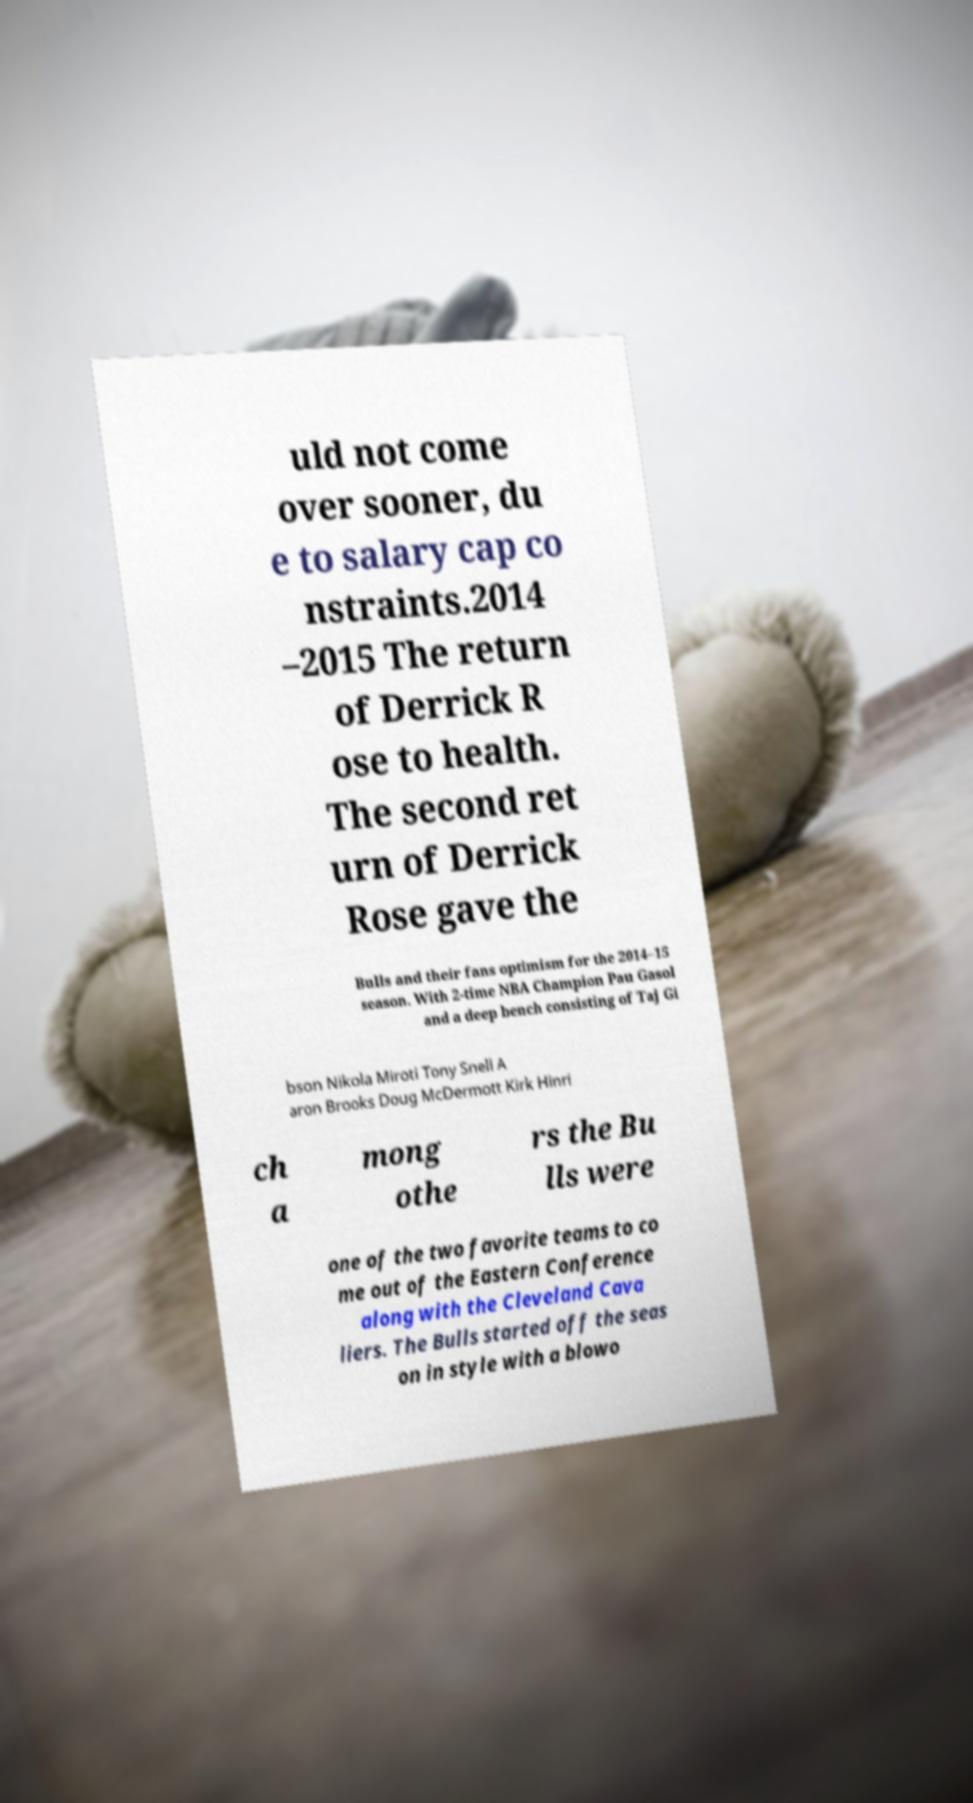What messages or text are displayed in this image? I need them in a readable, typed format. uld not come over sooner, du e to salary cap co nstraints.2014 –2015 The return of Derrick R ose to health. The second ret urn of Derrick Rose gave the Bulls and their fans optimism for the 2014–15 season. With 2-time NBA Champion Pau Gasol and a deep bench consisting of Taj Gi bson Nikola Miroti Tony Snell A aron Brooks Doug McDermott Kirk Hinri ch a mong othe rs the Bu lls were one of the two favorite teams to co me out of the Eastern Conference along with the Cleveland Cava liers. The Bulls started off the seas on in style with a blowo 